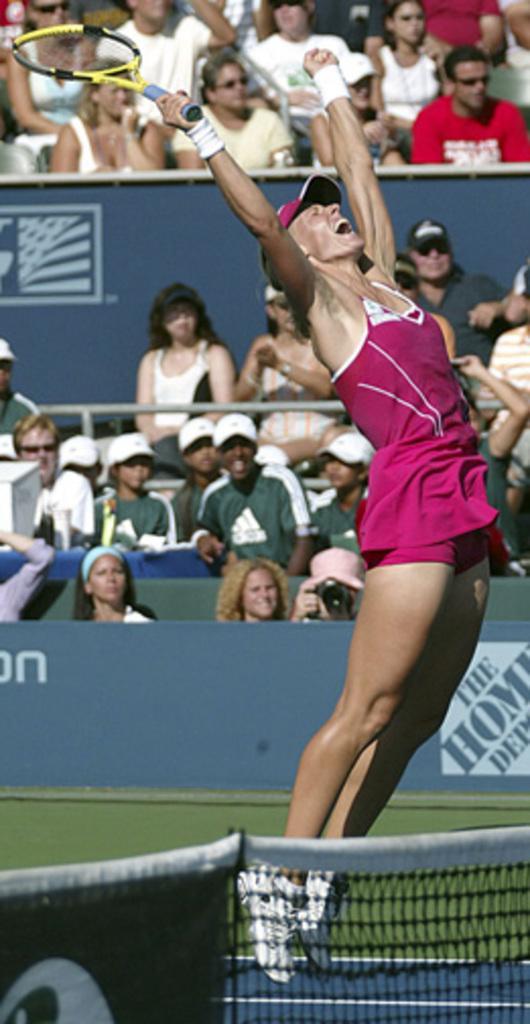In one or two sentences, can you explain what this image depicts? In this image I see a woman who is wearing a pink dress and she is holding a bat in her hands, I can also see she is wearing a cap. In the background I see people who are sitting and there is a net over here. 